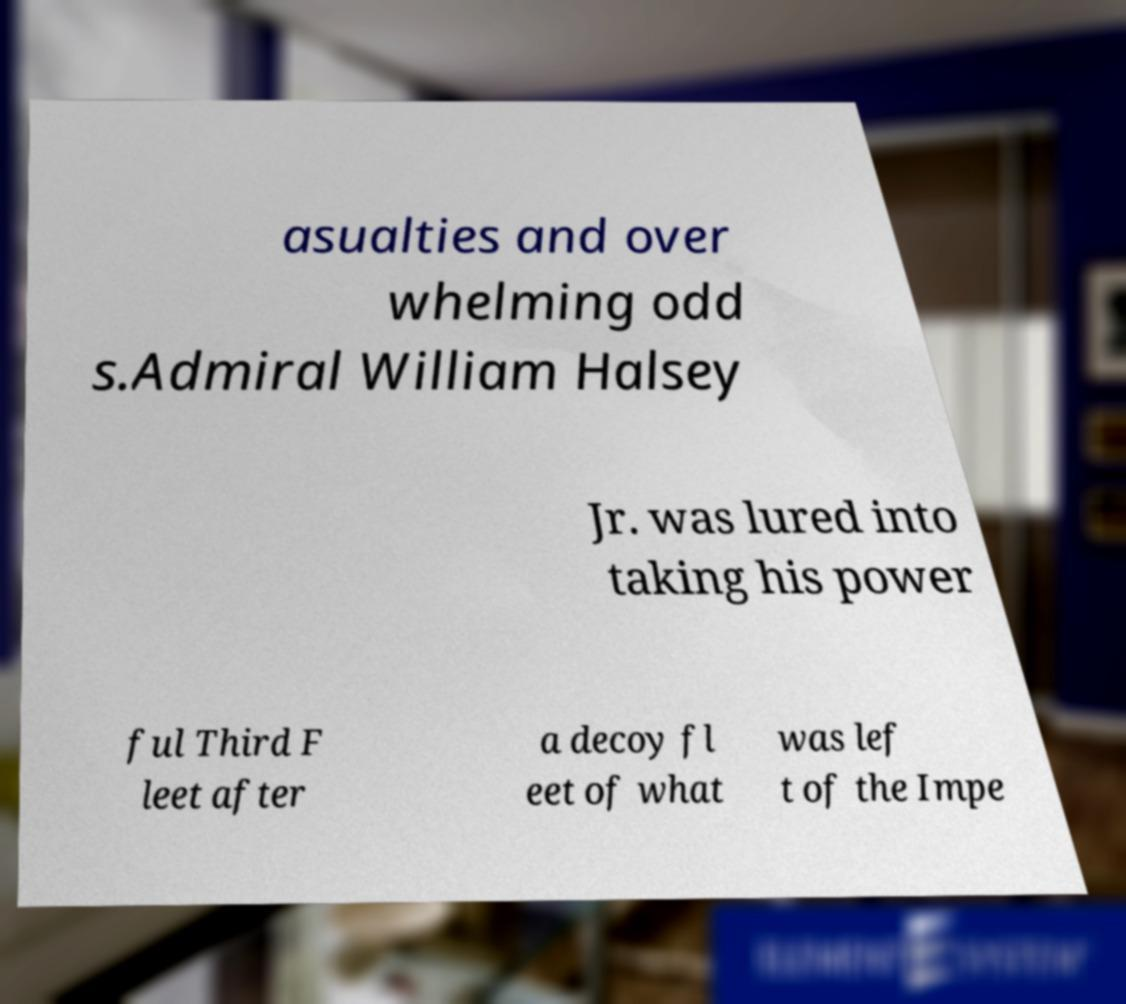Could you assist in decoding the text presented in this image and type it out clearly? asualties and over whelming odd s.Admiral William Halsey Jr. was lured into taking his power ful Third F leet after a decoy fl eet of what was lef t of the Impe 